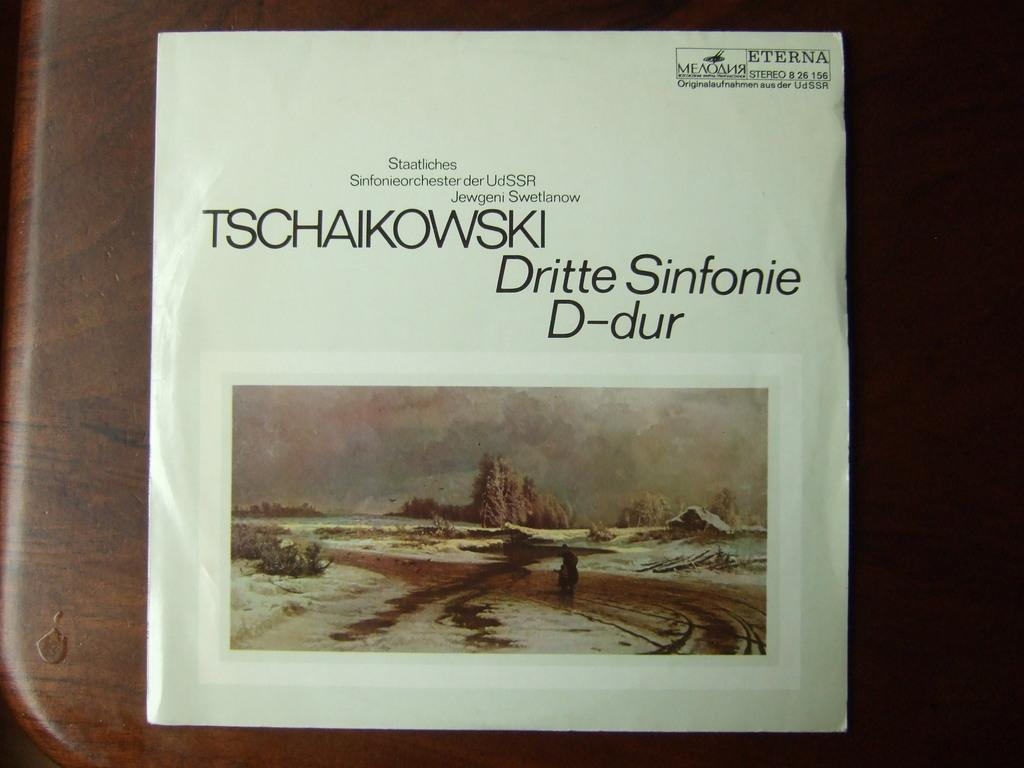Provide a one-sentence caption for the provided image. Tschaikowski's Dritte Sinfonie D-dur cover laying on a wooden table. 